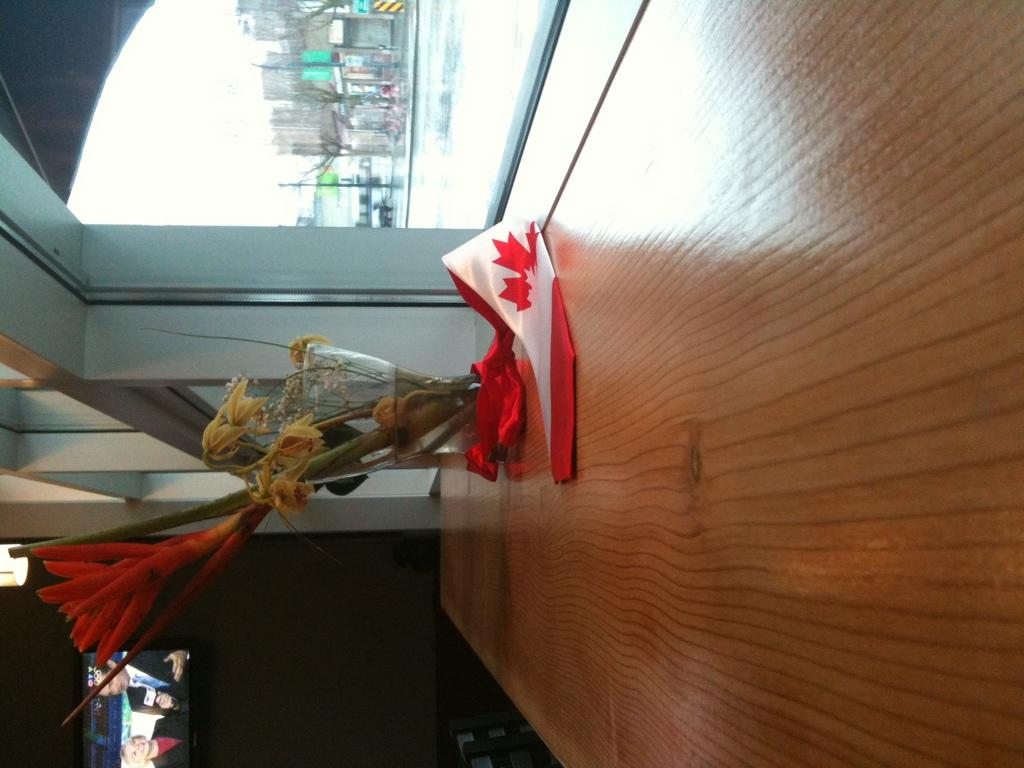What is located on the table in the foreground of the image? There is a flower vase on a table in the foreground. What can be seen through the window in the image? Water is visible in the image through the window. What type of structures can be seen in the image? There are buildings in the image. What other natural elements are present in the image? Trees are present in the image. What part of the natural environment is visible in the image? The sky is visible in the image. Based on the presence of the sky and the absence of artificial lighting, when do you think the image was likely taken? The image was likely taken during the day. What type of sheet is covering the bear in the image? There is no bear or sheet present in the image. 